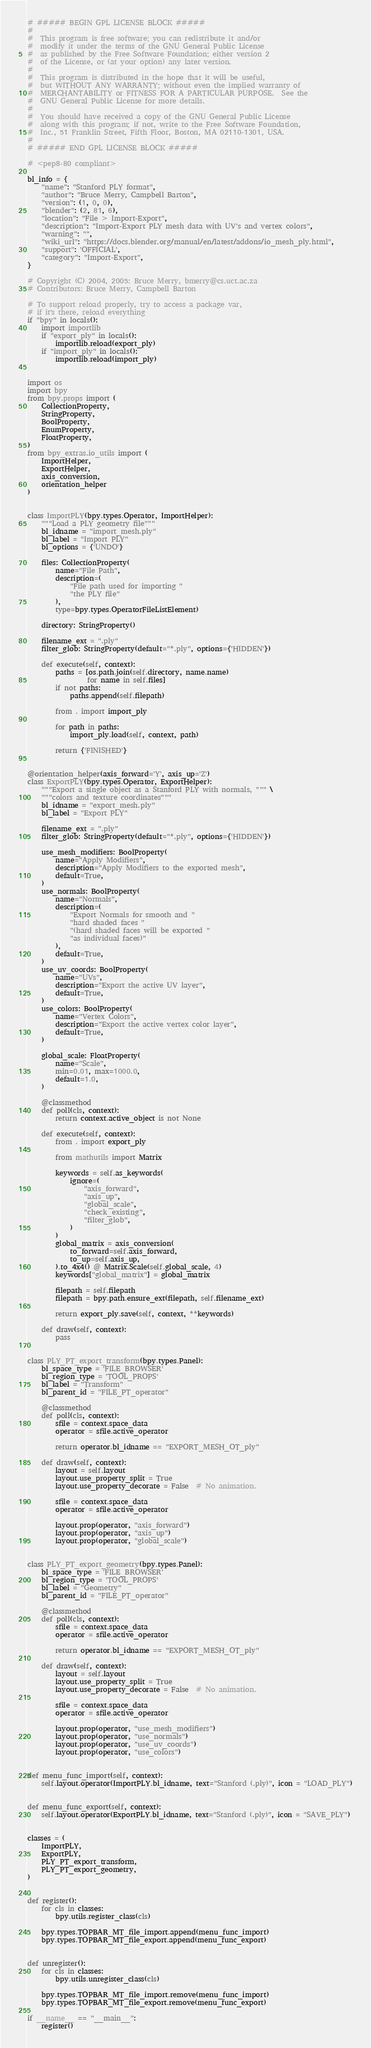<code> <loc_0><loc_0><loc_500><loc_500><_Python_># ##### BEGIN GPL LICENSE BLOCK #####
#
#  This program is free software; you can redistribute it and/or
#  modify it under the terms of the GNU General Public License
#  as published by the Free Software Foundation; either version 2
#  of the License, or (at your option) any later version.
#
#  This program is distributed in the hope that it will be useful,
#  but WITHOUT ANY WARRANTY; without even the implied warranty of
#  MERCHANTABILITY or FITNESS FOR A PARTICULAR PURPOSE.  See the
#  GNU General Public License for more details.
#
#  You should have received a copy of the GNU General Public License
#  along with this program; if not, write to the Free Software Foundation,
#  Inc., 51 Franklin Street, Fifth Floor, Boston, MA 02110-1301, USA.
#
# ##### END GPL LICENSE BLOCK #####

# <pep8-80 compliant>

bl_info = {
    "name": "Stanford PLY format",
    "author": "Bruce Merry, Campbell Barton",
    "version": (1, 0, 0),
    "blender": (2, 81, 6),
    "location": "File > Import-Export",
    "description": "Import-Export PLY mesh data with UV's and vertex colors",
    "warning": "",
    "wiki_url": "https://docs.blender.org/manual/en/latest/addons/io_mesh_ply.html",
    "support": 'OFFICIAL',
    "category": "Import-Export",
}

# Copyright (C) 2004, 2005: Bruce Merry, bmerry@cs.uct.ac.za
# Contributors: Bruce Merry, Campbell Barton

# To support reload properly, try to access a package var,
# if it's there, reload everything
if "bpy" in locals():
    import importlib
    if "export_ply" in locals():
        importlib.reload(export_ply)
    if "import_ply" in locals():
        importlib.reload(import_ply)


import os
import bpy
from bpy.props import (
    CollectionProperty,
    StringProperty,
    BoolProperty,
    EnumProperty,
    FloatProperty,
)
from bpy_extras.io_utils import (
    ImportHelper,
    ExportHelper,
    axis_conversion,
    orientation_helper
)


class ImportPLY(bpy.types.Operator, ImportHelper):
    """Load a PLY geometry file"""
    bl_idname = "import_mesh.ply"
    bl_label = "Import PLY"
    bl_options = {'UNDO'}

    files: CollectionProperty(
        name="File Path",
        description=(
            "File path used for importing "
            "the PLY file"
        ),
        type=bpy.types.OperatorFileListElement)

    directory: StringProperty()

    filename_ext = ".ply"
    filter_glob: StringProperty(default="*.ply", options={'HIDDEN'})

    def execute(self, context):
        paths = [os.path.join(self.directory, name.name)
                 for name in self.files]
        if not paths:
            paths.append(self.filepath)

        from . import import_ply

        for path in paths:
            import_ply.load(self, context, path)

        return {'FINISHED'}


@orientation_helper(axis_forward='Y', axis_up='Z')
class ExportPLY(bpy.types.Operator, ExportHelper):
    """Export a single object as a Stanford PLY with normals, """ \
    """colors and texture coordinates"""
    bl_idname = "export_mesh.ply"
    bl_label = "Export PLY"

    filename_ext = ".ply"
    filter_glob: StringProperty(default="*.ply", options={'HIDDEN'})

    use_mesh_modifiers: BoolProperty(
        name="Apply Modifiers",
        description="Apply Modifiers to the exported mesh",
        default=True,
    )
    use_normals: BoolProperty(
        name="Normals",
        description=(
            "Export Normals for smooth and "
            "hard shaded faces "
            "(hard shaded faces will be exported "
            "as individual faces)"
        ),
        default=True,
    )
    use_uv_coords: BoolProperty(
        name="UVs",
        description="Export the active UV layer",
        default=True,
    )
    use_colors: BoolProperty(
        name="Vertex Colors",
        description="Export the active vertex color layer",
        default=True,
    )

    global_scale: FloatProperty(
        name="Scale",
        min=0.01, max=1000.0,
        default=1.0,
    )

    @classmethod
    def poll(cls, context):
        return context.active_object is not None

    def execute(self, context):
        from . import export_ply

        from mathutils import Matrix

        keywords = self.as_keywords(
            ignore=(
                "axis_forward",
                "axis_up",
                "global_scale",
                "check_existing",
                "filter_glob",
            )
        )
        global_matrix = axis_conversion(
            to_forward=self.axis_forward,
            to_up=self.axis_up,
        ).to_4x4() @ Matrix.Scale(self.global_scale, 4)
        keywords["global_matrix"] = global_matrix

        filepath = self.filepath
        filepath = bpy.path.ensure_ext(filepath, self.filename_ext)

        return export_ply.save(self, context, **keywords)

    def draw(self, context):
        pass


class PLY_PT_export_transform(bpy.types.Panel):
    bl_space_type = 'FILE_BROWSER'
    bl_region_type = 'TOOL_PROPS'
    bl_label = "Transform"
    bl_parent_id = "FILE_PT_operator"

    @classmethod
    def poll(cls, context):
        sfile = context.space_data
        operator = sfile.active_operator

        return operator.bl_idname == "EXPORT_MESH_OT_ply"

    def draw(self, context):
        layout = self.layout
        layout.use_property_split = True
        layout.use_property_decorate = False  # No animation.

        sfile = context.space_data
        operator = sfile.active_operator

        layout.prop(operator, "axis_forward")
        layout.prop(operator, "axis_up")
        layout.prop(operator, "global_scale")


class PLY_PT_export_geometry(bpy.types.Panel):
    bl_space_type = 'FILE_BROWSER'
    bl_region_type = 'TOOL_PROPS'
    bl_label = "Geometry"
    bl_parent_id = "FILE_PT_operator"

    @classmethod
    def poll(cls, context):
        sfile = context.space_data
        operator = sfile.active_operator

        return operator.bl_idname == "EXPORT_MESH_OT_ply"

    def draw(self, context):
        layout = self.layout
        layout.use_property_split = True
        layout.use_property_decorate = False  # No animation.

        sfile = context.space_data
        operator = sfile.active_operator

        layout.prop(operator, "use_mesh_modifiers")
        layout.prop(operator, "use_normals")
        layout.prop(operator, "use_uv_coords")
        layout.prop(operator, "use_colors")


def menu_func_import(self, context):
    self.layout.operator(ImportPLY.bl_idname, text="Stanford (.ply)", icon = "LOAD_PLY")


def menu_func_export(self, context):
    self.layout.operator(ExportPLY.bl_idname, text="Stanford (.ply)", icon = "SAVE_PLY")


classes = (
    ImportPLY,
    ExportPLY,
    PLY_PT_export_transform,
    PLY_PT_export_geometry,
)


def register():
    for cls in classes:
        bpy.utils.register_class(cls)

    bpy.types.TOPBAR_MT_file_import.append(menu_func_import)
    bpy.types.TOPBAR_MT_file_export.append(menu_func_export)


def unregister():
    for cls in classes:
        bpy.utils.unregister_class(cls)

    bpy.types.TOPBAR_MT_file_import.remove(menu_func_import)
    bpy.types.TOPBAR_MT_file_export.remove(menu_func_export)

if __name__ == "__main__":
    register()
</code> 